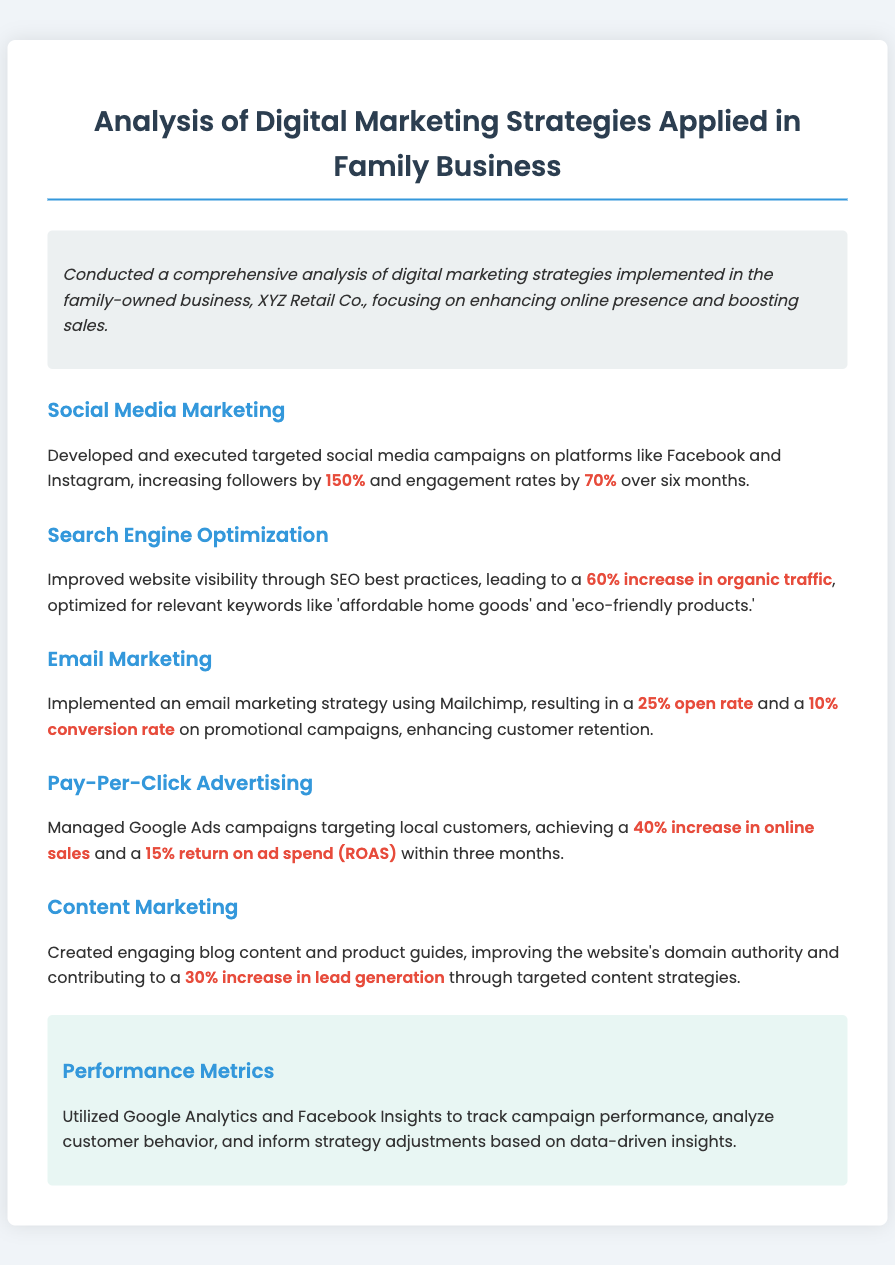What is the name of the family business? The document mentions the family-owned business as XYZ Retail Co.
Answer: XYZ Retail Co What percentage did followers increase on social media? The document states that followers increased by 150%.
Answer: 150% What was the increase in organic traffic due to SEO? According to the document, there was a 60% increase in organic traffic.
Answer: 60% What tool was used for the email marketing strategy? The document specifies that Mailchimp was used for the email marketing strategy.
Answer: Mailchimp What was the conversion rate for promotional campaigns? The document indicates a 10% conversion rate for promotional campaigns.
Answer: 10% What was the return on ad spend achieved through Google Ads? The document states a 15% return on ad spend (ROAS) achieved within three months.
Answer: 15% What content strategy led to a 30% increase in lead generation? Engaging blog content and product guides led to the increase in lead generation.
Answer: Engaging blog content and product guides What metrics were utilized to track campaign performance? The document mentions Google Analytics and Facebook Insights as the metrics utilized.
Answer: Google Analytics and Facebook Insights What was the overall focus of the digital marketing analysis? The document states the focus was on enhancing online presence and boosting sales.
Answer: Enhancing online presence and boosting sales 